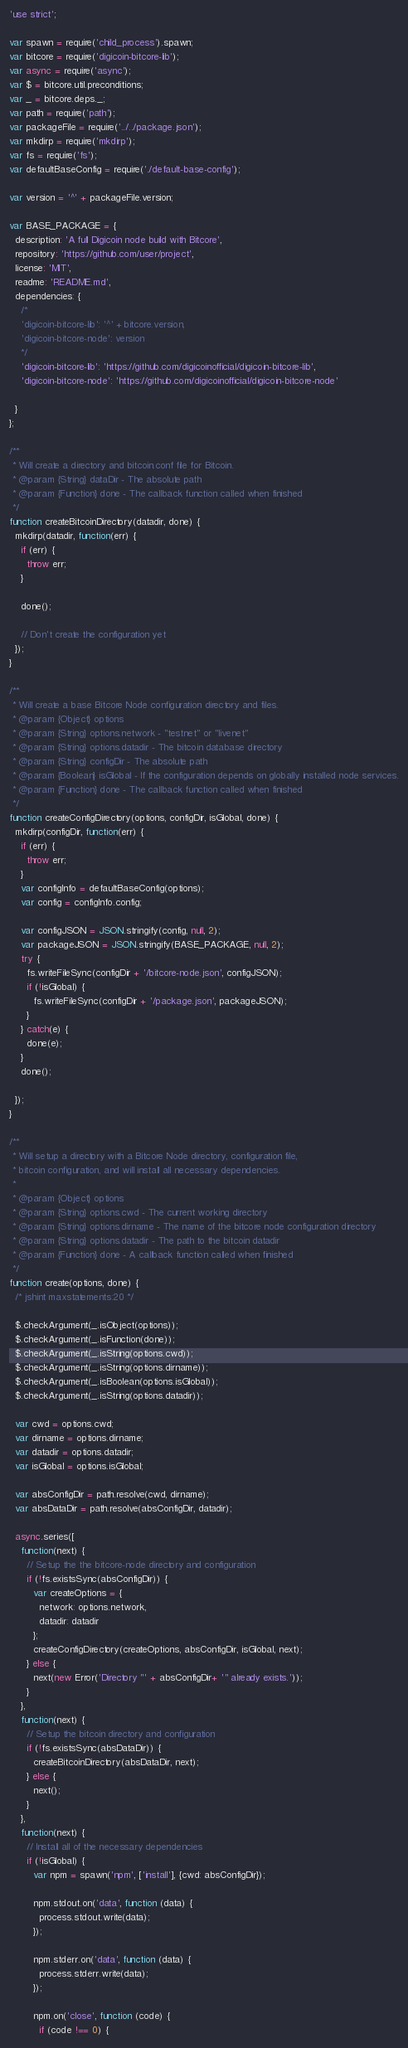Convert code to text. <code><loc_0><loc_0><loc_500><loc_500><_JavaScript_>'use strict';

var spawn = require('child_process').spawn;
var bitcore = require('digicoin-bitcore-lib');
var async = require('async');
var $ = bitcore.util.preconditions;
var _ = bitcore.deps._;
var path = require('path');
var packageFile = require('../../package.json');
var mkdirp = require('mkdirp');
var fs = require('fs');
var defaultBaseConfig = require('./default-base-config');

var version = '^' + packageFile.version;

var BASE_PACKAGE = {
  description: 'A full Digicoin node build with Bitcore',
  repository: 'https://github.com/user/project',
  license: 'MIT',
  readme: 'README.md',
  dependencies: {
    /*
    'digicoin-bitcore-lib': '^' + bitcore.version,
    'digicoin-bitcore-node': version
    */
    'digicoin-bitcore-lib': 'https://github.com/digicoinofficial/digicoin-bitcore-lib',
    'digicoin-bitcore-node': 'https://github.com/digicoinofficial/digicoin-bitcore-node'
    
  }
};

/**
 * Will create a directory and bitcoin.conf file for Bitcoin.
 * @param {String} dataDir - The absolute path
 * @param {Function} done - The callback function called when finished
 */
function createBitcoinDirectory(datadir, done) {
  mkdirp(datadir, function(err) {
    if (err) {
      throw err;
    }

    done();

    // Don't create the configuration yet
  });
}

/**
 * Will create a base Bitcore Node configuration directory and files.
 * @param {Object} options
 * @param {String} options.network - "testnet" or "livenet"
 * @param {String} options.datadir - The bitcoin database directory
 * @param {String} configDir - The absolute path
 * @param {Boolean} isGlobal - If the configuration depends on globally installed node services.
 * @param {Function} done - The callback function called when finished
 */
function createConfigDirectory(options, configDir, isGlobal, done) {
  mkdirp(configDir, function(err) {
    if (err) {
      throw err;
    }
    var configInfo = defaultBaseConfig(options);
    var config = configInfo.config;

    var configJSON = JSON.stringify(config, null, 2);
    var packageJSON = JSON.stringify(BASE_PACKAGE, null, 2);
    try {
      fs.writeFileSync(configDir + '/bitcore-node.json', configJSON);
      if (!isGlobal) {
        fs.writeFileSync(configDir + '/package.json', packageJSON);
      }
    } catch(e) {
      done(e);
    }
    done();

  });
}

/**
 * Will setup a directory with a Bitcore Node directory, configuration file,
 * bitcoin configuration, and will install all necessary dependencies.
 *
 * @param {Object} options
 * @param {String} options.cwd - The current working directory
 * @param {String} options.dirname - The name of the bitcore node configuration directory
 * @param {String} options.datadir - The path to the bitcoin datadir
 * @param {Function} done - A callback function called when finished
 */
function create(options, done) {
  /* jshint maxstatements:20 */

  $.checkArgument(_.isObject(options));
  $.checkArgument(_.isFunction(done));
  $.checkArgument(_.isString(options.cwd));
  $.checkArgument(_.isString(options.dirname));
  $.checkArgument(_.isBoolean(options.isGlobal));
  $.checkArgument(_.isString(options.datadir));

  var cwd = options.cwd;
  var dirname = options.dirname;
  var datadir = options.datadir;
  var isGlobal = options.isGlobal;

  var absConfigDir = path.resolve(cwd, dirname);
  var absDataDir = path.resolve(absConfigDir, datadir);

  async.series([
    function(next) {
      // Setup the the bitcore-node directory and configuration
      if (!fs.existsSync(absConfigDir)) {
        var createOptions = {
          network: options.network,
          datadir: datadir
        };
        createConfigDirectory(createOptions, absConfigDir, isGlobal, next);
      } else {
        next(new Error('Directory "' + absConfigDir+ '" already exists.'));
      }
    },
    function(next) {
      // Setup the bitcoin directory and configuration
      if (!fs.existsSync(absDataDir)) {
        createBitcoinDirectory(absDataDir, next);
      } else {
        next();
      }
    },
    function(next) {
      // Install all of the necessary dependencies
      if (!isGlobal) {
        var npm = spawn('npm', ['install'], {cwd: absConfigDir});

        npm.stdout.on('data', function (data) {
          process.stdout.write(data);
        });

        npm.stderr.on('data', function (data) {
          process.stderr.write(data);
        });

        npm.on('close', function (code) {
          if (code !== 0) {</code> 